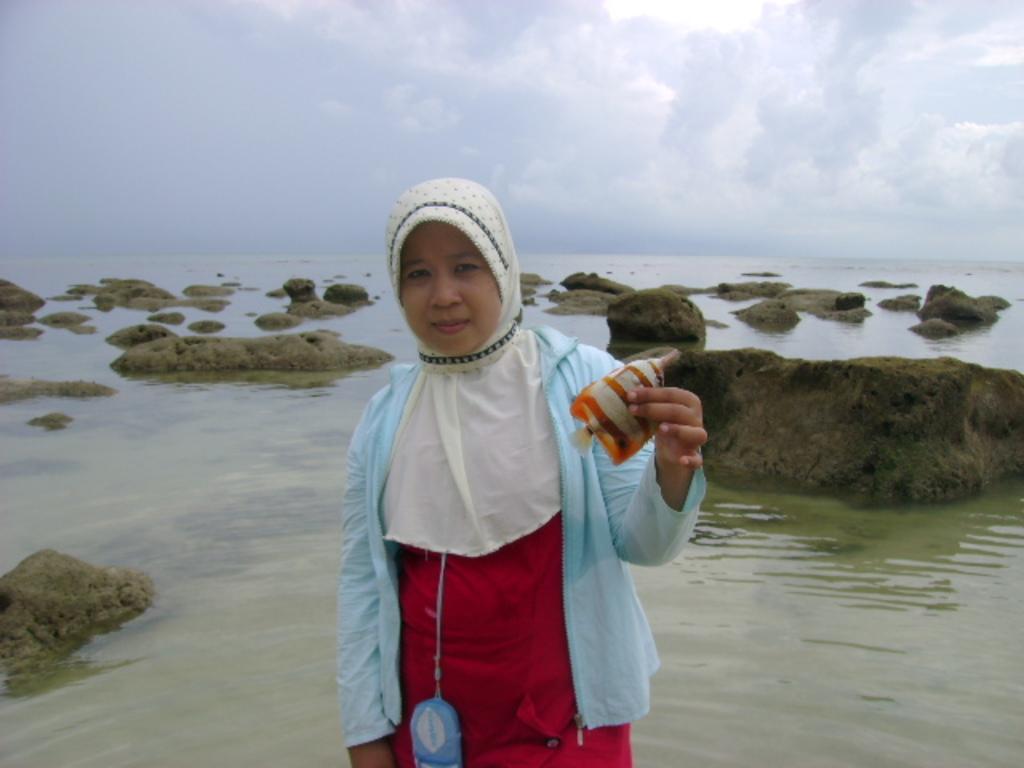Please provide a concise description of this image. In the picture we can see a woman standing in the water and holding a fish in the hand and behind her we can see water with some rocks in it and in the background we can see a sky with clouds. 